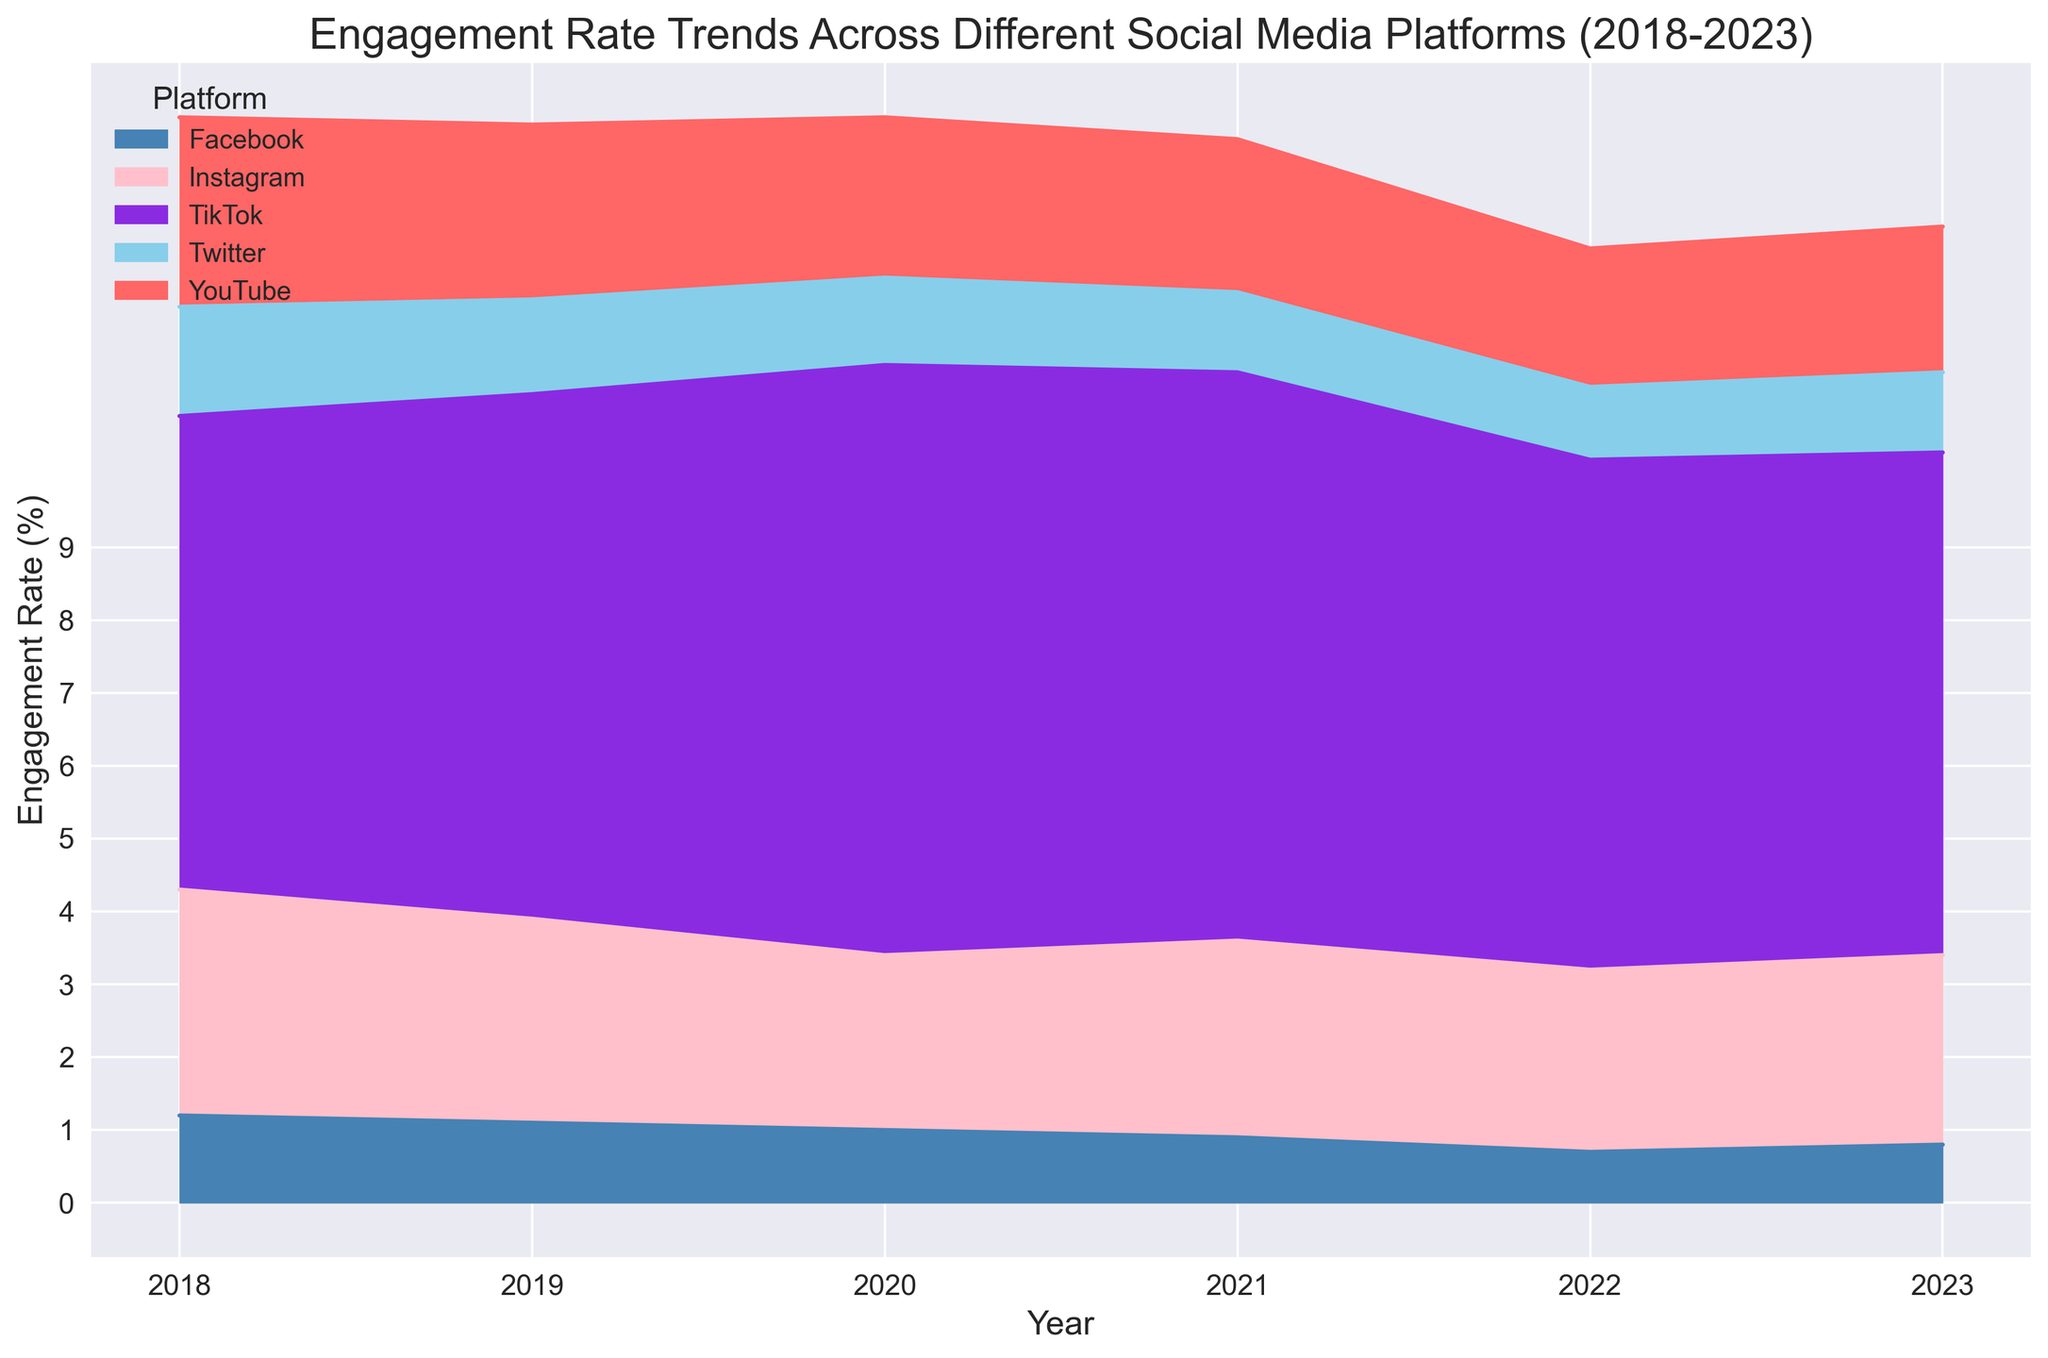Which platform had the highest engagement rate in 2018? By looking at the height of the areas for each platform in 2018, it is clear that TikTok had the highest engagement rate compared to other platforms.
Answer: TikTok How did the engagement rate on Instagram change from 2018 to 2023? In 2018, Instagram's engagement rate was 3.1%. By 2023, it decreased to 2.6%. The difference between these years is 3.1% - 2.6%, showing a decrease.
Answer: Decreased by 0.5% Which platform experienced the most volatile engagement rate trends over the last five years? By observing the graph areas, TikTok shows the most significant changes in its engagement rates, with notable increases and decreases compared to other platforms.
Answer: TikTok Did YouTube's engagement rate ever fall below Twitter's in the given period? Reviewing the plot, YouTube's engagement rate is always above Twitter's engagement rate for each year from 2018 to 2023.
Answer: No What was the trend for Facebook's engagement rate from 2018 to 2023? The area representing Facebook shows a continuous decline from 1.2% in 2018 to 0.8% in 2023.
Answer: Declining What is the difference in engagement rate between TikTok and Twitter in 2020? In 2020, TikTok had an engagement rate of 8.1%, while Twitter's engagement rate was 1.2%. The difference is calculated as 8.1% - 1.2%.
Answer: 6.9% Which platform had the least engagement rate in 2022? In 2022, the shortest area segment belongs to Facebook, indicating it had the lowest engagement rate of 0.7%.
Answer: Facebook How does TikTok's engagement rate in 2023 compare to its rate in 2019? TikTok's engagement rate was 7.2% in 2019 and 6.9% in 2023, showing a decrease of 7.2% - 6.9%.
Answer: Decreased by 0.3% What can you infer about the overall trend of engagement rates on Twitter from 2018 to 2023? The area for Twitter shows a steady decline from 1.5% in 2018 to 1.1% in 2023, indicating a decreasing trend.
Answer: Declining Which year did Instagram see the lowest engagement rate? Observing the areas for Instagram, the smallest portion appears in 2020 with an engagement rate of 2.4%.
Answer: 2020 